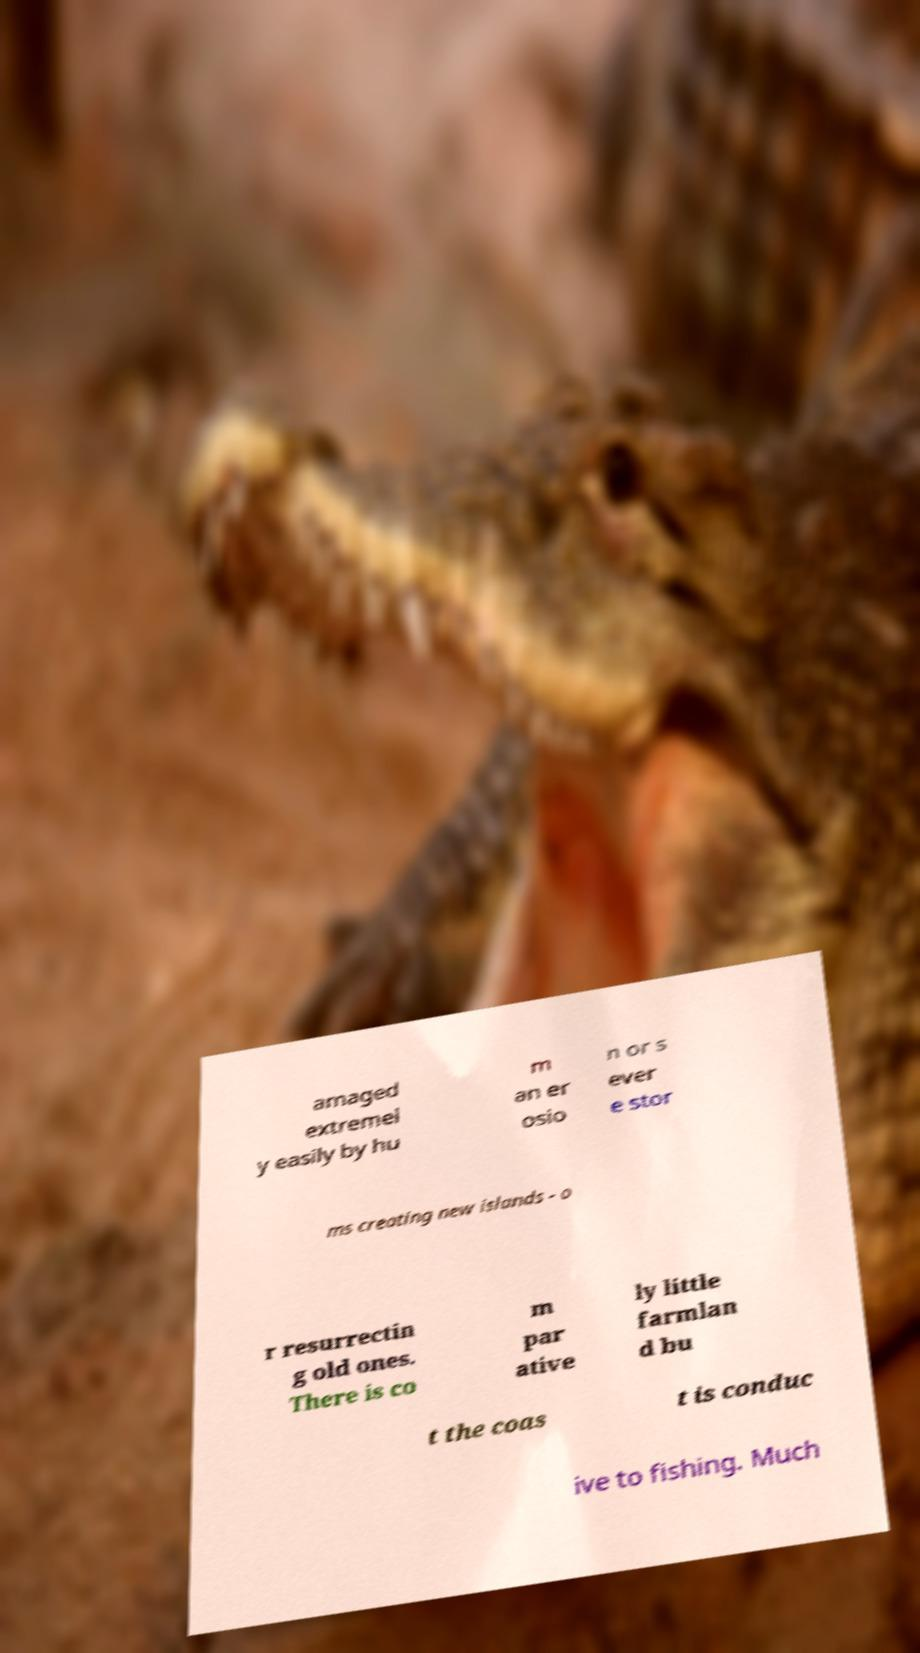Could you assist in decoding the text presented in this image and type it out clearly? amaged extremel y easily by hu m an er osio n or s ever e stor ms creating new islands - o r resurrectin g old ones. There is co m par ative ly little farmlan d bu t the coas t is conduc ive to fishing. Much 